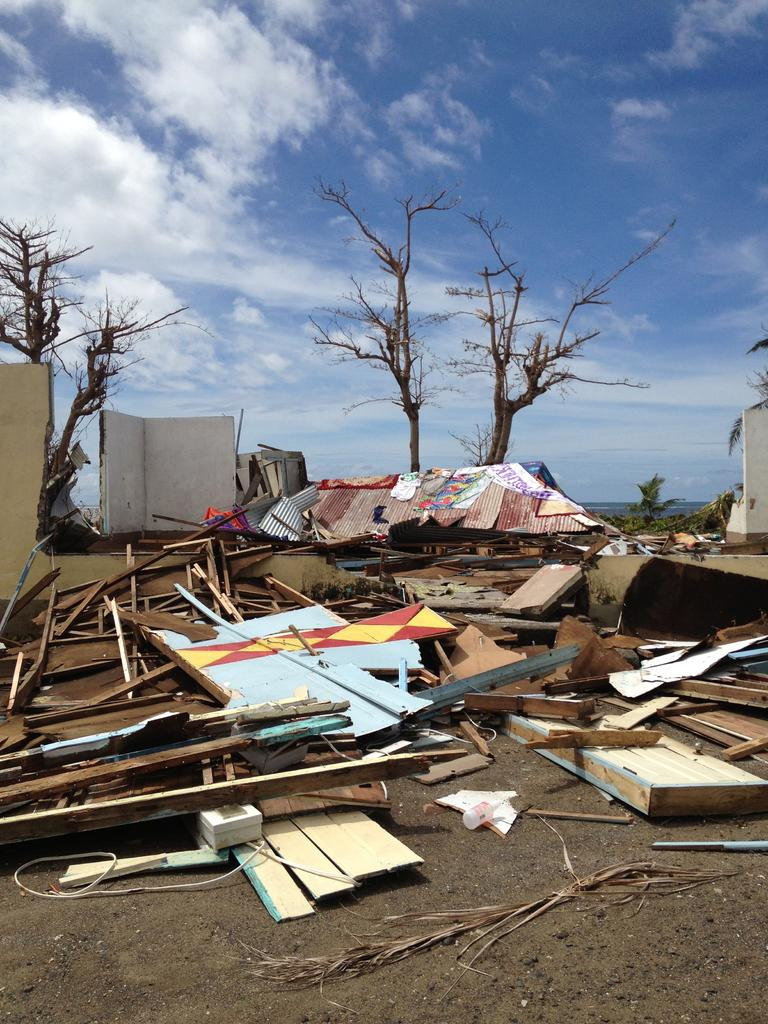What objects are on the floor in the image? There are wooden sticks on the floor. What type of natural environment can be seen in the image? There are trees visible in the image. What part of the natural environment is visible in the image? The sky is visible in the image. What type of vest can be seen hanging on the trees in the image? There are no vests present in the image; it features wooden sticks on the floor and trees in the background. 